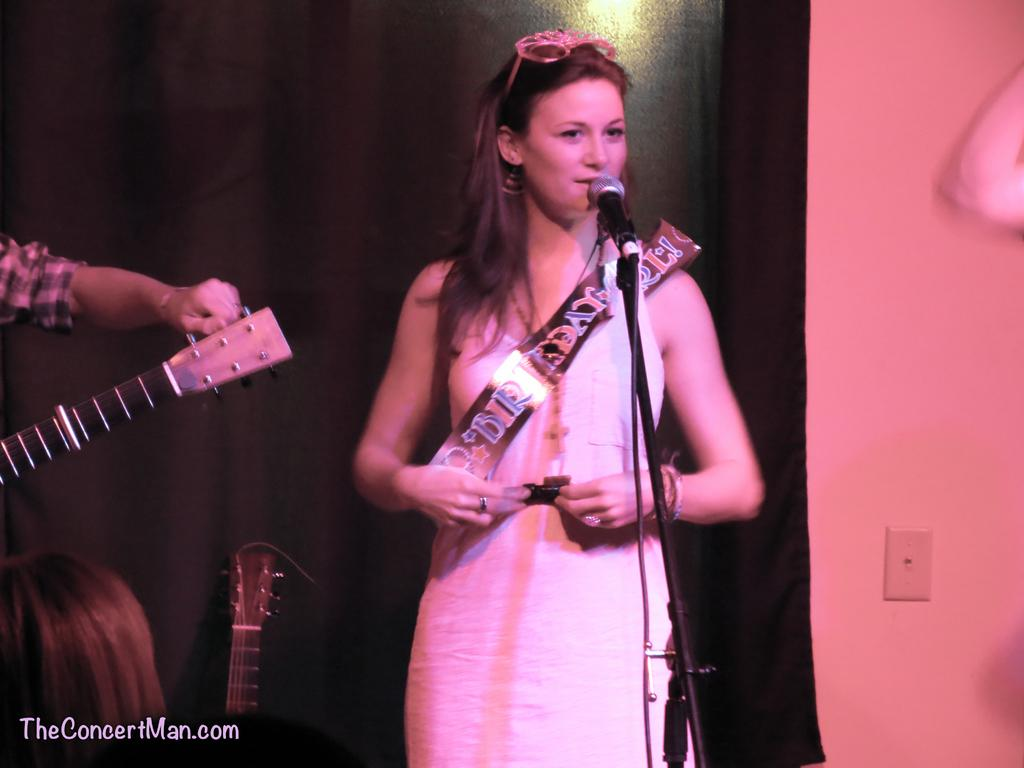What is the woman in the image doing? The woman is standing behind a microphone. What instrument is the person on the left side of the image holding? The person on the left side of the image is holding a guitar. Can you describe the cloth visible in the image? Unfortunately, the facts provided do not give any details about the cloth. What else can be seen in the background of the image? There is another guitar visible in the background. What type of selection process is being conducted in the image? There is no indication of a selection process in the image; it features a woman standing behind a microphone and a person holding a guitar. How many sides does the guitar on the left side of the image have? The facts provided do not give any details about the number of sides of the guitar. 